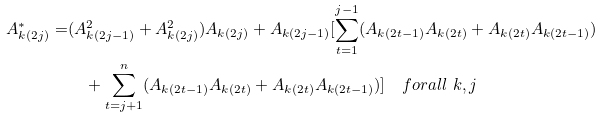Convert formula to latex. <formula><loc_0><loc_0><loc_500><loc_500>A _ { k ( 2 j ) } ^ { * } = & ( A _ { k ( 2 j - 1 ) } ^ { 2 } + A _ { k ( 2 j ) } ^ { 2 } ) A _ { k ( 2 j ) } + A _ { k ( 2 j - 1 ) } [ \sum _ { t = 1 } ^ { j - 1 } ( A _ { k ( 2 t - 1 ) } A _ { k ( 2 t ) } + A _ { k ( 2 t ) } A _ { k ( 2 t - 1 ) } ) \\ & \quad + \sum _ { t = j + 1 } ^ { n } ( A _ { k ( 2 t - 1 ) } A _ { k ( 2 t ) } + A _ { k ( 2 t ) } A _ { k ( 2 t - 1 ) } ) ] \quad f o r a l l \ k , j</formula> 